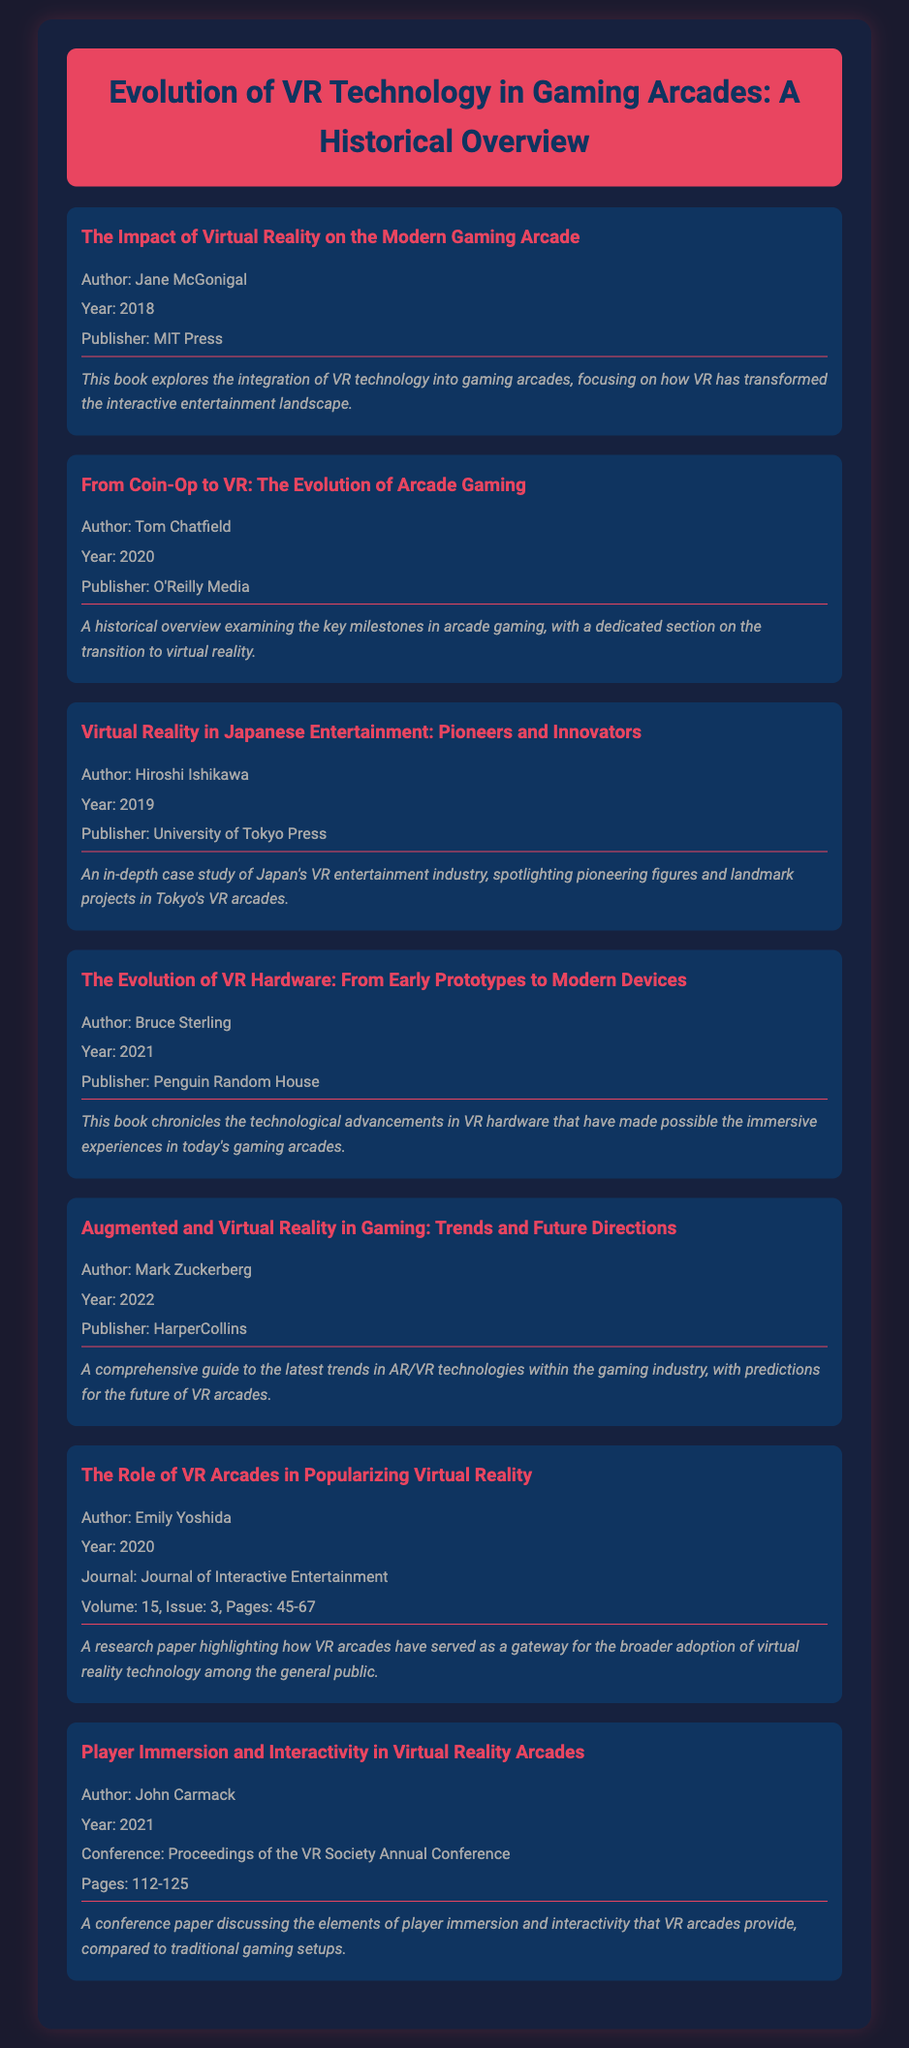What is the title of the first item? The first item's title is found in the document, referring to the work by Jane McGonigal.
Answer: The Impact of Virtual Reality on the Modern Gaming Arcade Who is the author of the book published by MIT Press? This information can be retrieved directly from the first bibliography item's details.
Answer: Jane McGonigal In what year was "From Coin-Op to VR" published? The year of publication is clearly stated in the second bibliography item.
Answer: 2020 What kind of publication is the sixth item categorized as? The sixth item's entry indicates it is a research paper published in a journal.
Answer: Journal How many pages does the conference paper by John Carmack cover? The pages of the conference paper are listed within its citation in the document.
Answer: 112-125 Which publisher released "Augmented and Virtual Reality in Gaming"? This detail can be found in the item's citation, specifying the publishing house involved.
Answer: HarperCollins Which author's work focuses on the role of VR arcades? The specific author is mentioned in the sixth bibliography item.
Answer: Emily Yoshida What section is dedicated to VR technology integration in the first item? The first item provides insight into how VR has transformed a specific aspect of gaming.
Answer: Interactive entertainment landscape 